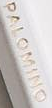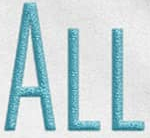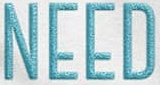Identify the words shown in these images in order, separated by a semicolon. PALOMINO; ALL; NEED 